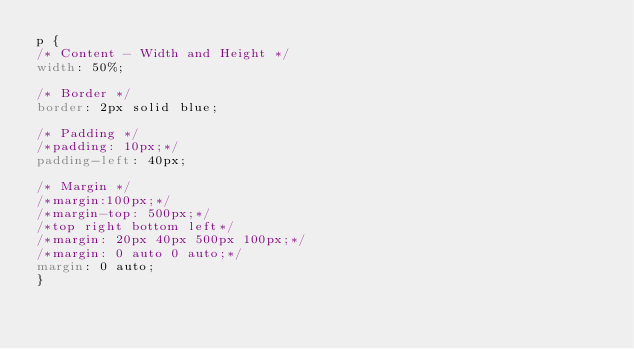<code> <loc_0><loc_0><loc_500><loc_500><_CSS_>p {
/* Content - Width and Height */
width: 50%;

/* Border */
border: 2px solid blue;

/* Padding */
/*padding: 10px;*/
padding-left: 40px;

/* Margin */
/*margin:100px;*/
/*margin-top: 500px;*/
/*top right bottom left*/
/*margin: 20px 40px 500px 100px;*/
/*margin: 0 auto 0 auto;*/
margin: 0 auto;
}</code> 